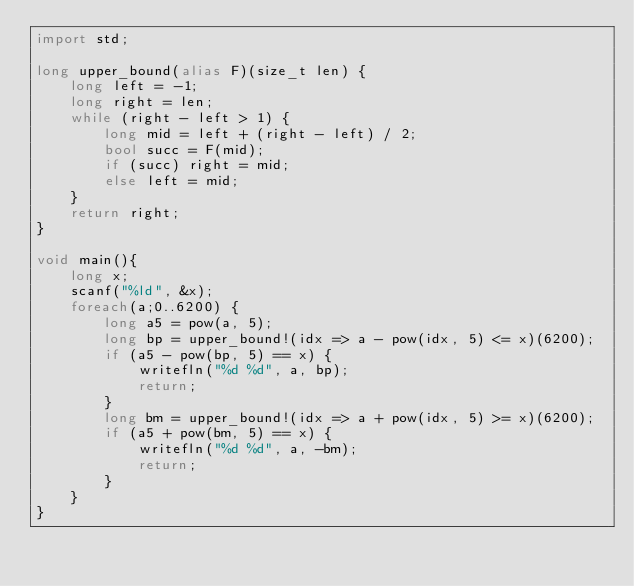<code> <loc_0><loc_0><loc_500><loc_500><_D_>import std;

long upper_bound(alias F)(size_t len) {
	long left = -1;
	long right = len;
	while (right - left > 1) {
		long mid = left + (right - left) / 2;
		bool succ = F(mid);
		if (succ) right = mid;
		else left = mid;
	}
	return right;
}

void main(){ 
	long x;
	scanf("%ld", &x);
	foreach(a;0..6200) {
		long a5 = pow(a, 5);
		long bp = upper_bound!(idx => a - pow(idx, 5) <= x)(6200);
		if (a5 - pow(bp, 5) == x) {
			writefln("%d %d", a, bp);
			return;
		}
		long bm = upper_bound!(idx => a + pow(idx, 5) >= x)(6200);
		if (a5 + pow(bm, 5) == x) {
			writefln("%d %d", a, -bm);
			return;
		}
	}
}
</code> 